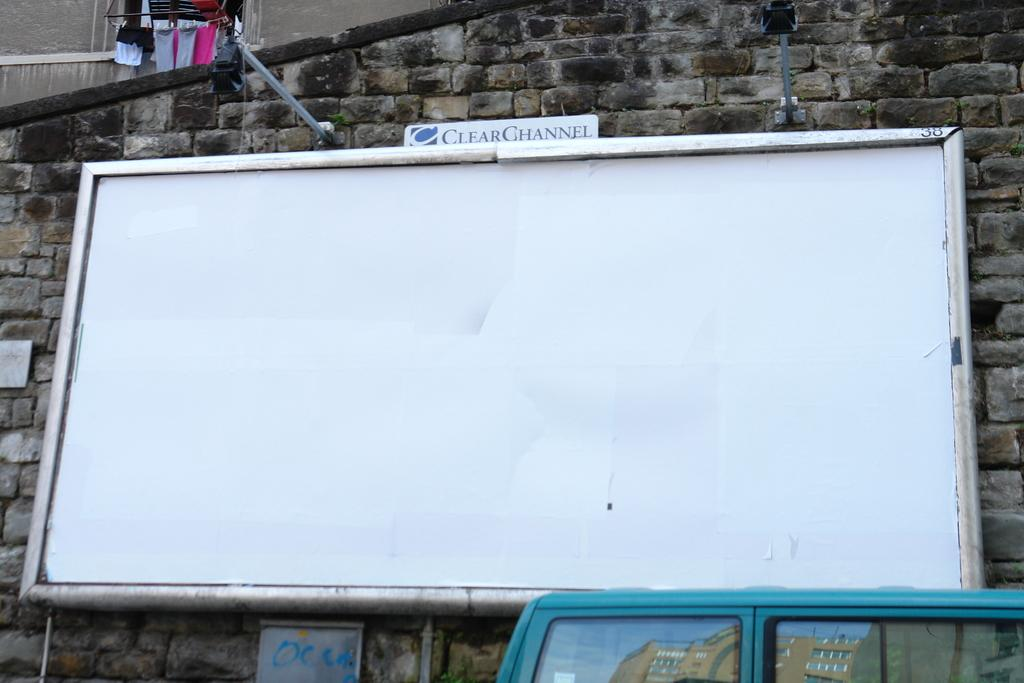Provide a one-sentence caption for the provided image. A large whiteboard is empty with the words CLEAR CHANNEL above it. 